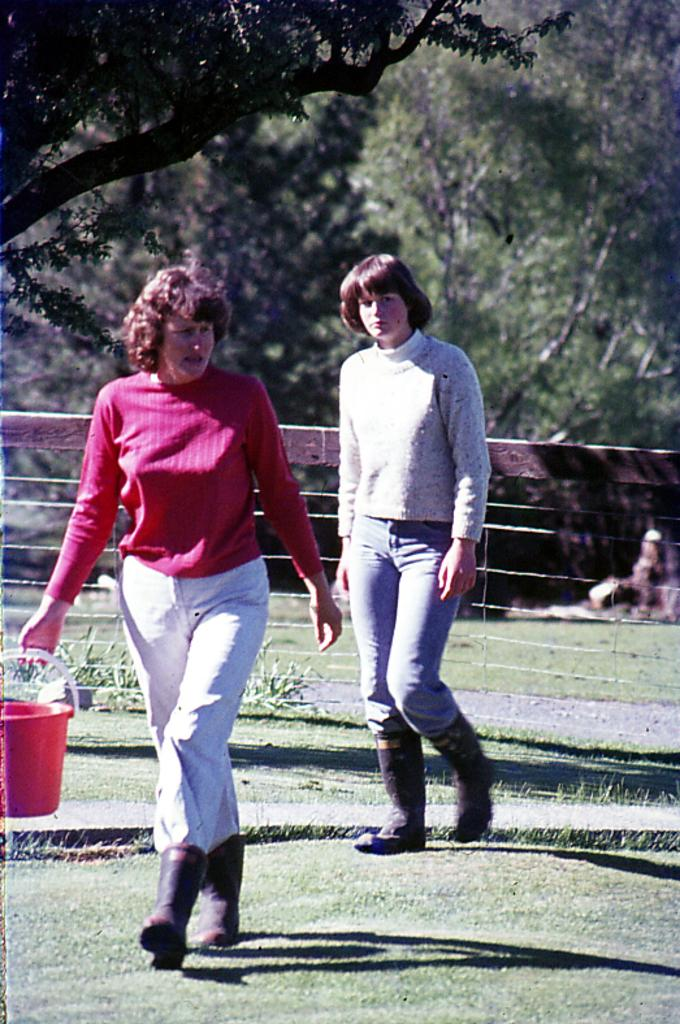How many women are in the image? There are two women in the image. What are the women doing in the image? The women are standing on the ground. What is one of the women holding in her hand? One woman is holding a bucket in her hand. What can be seen in the background of the image? There is a fence, a group of plants, trees, and grass in the background of the image. What type of print can be seen on the women's clothing in the image? There is no information about the women's clothing or any prints in the provided facts, so we cannot answer this question. 